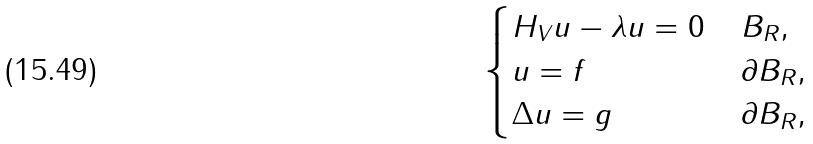Convert formula to latex. <formula><loc_0><loc_0><loc_500><loc_500>\begin{cases} H _ { V } u - \lambda u = 0 & \, B _ { R } , \\ u = f & \, \partial B _ { R } , \\ \Delta u = g & \, \partial B _ { R } , \end{cases}</formula> 